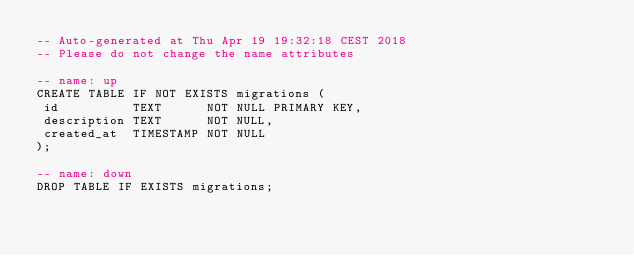Convert code to text. <code><loc_0><loc_0><loc_500><loc_500><_SQL_>-- Auto-generated at Thu Apr 19 19:32:18 CEST 2018
-- Please do not change the name attributes

-- name: up
CREATE TABLE IF NOT EXISTS migrations (
 id          TEXT      NOT NULL PRIMARY KEY,
 description TEXT      NOT NULL,
 created_at  TIMESTAMP NOT NULL
);

-- name: down
DROP TABLE IF EXISTS migrations;
</code> 